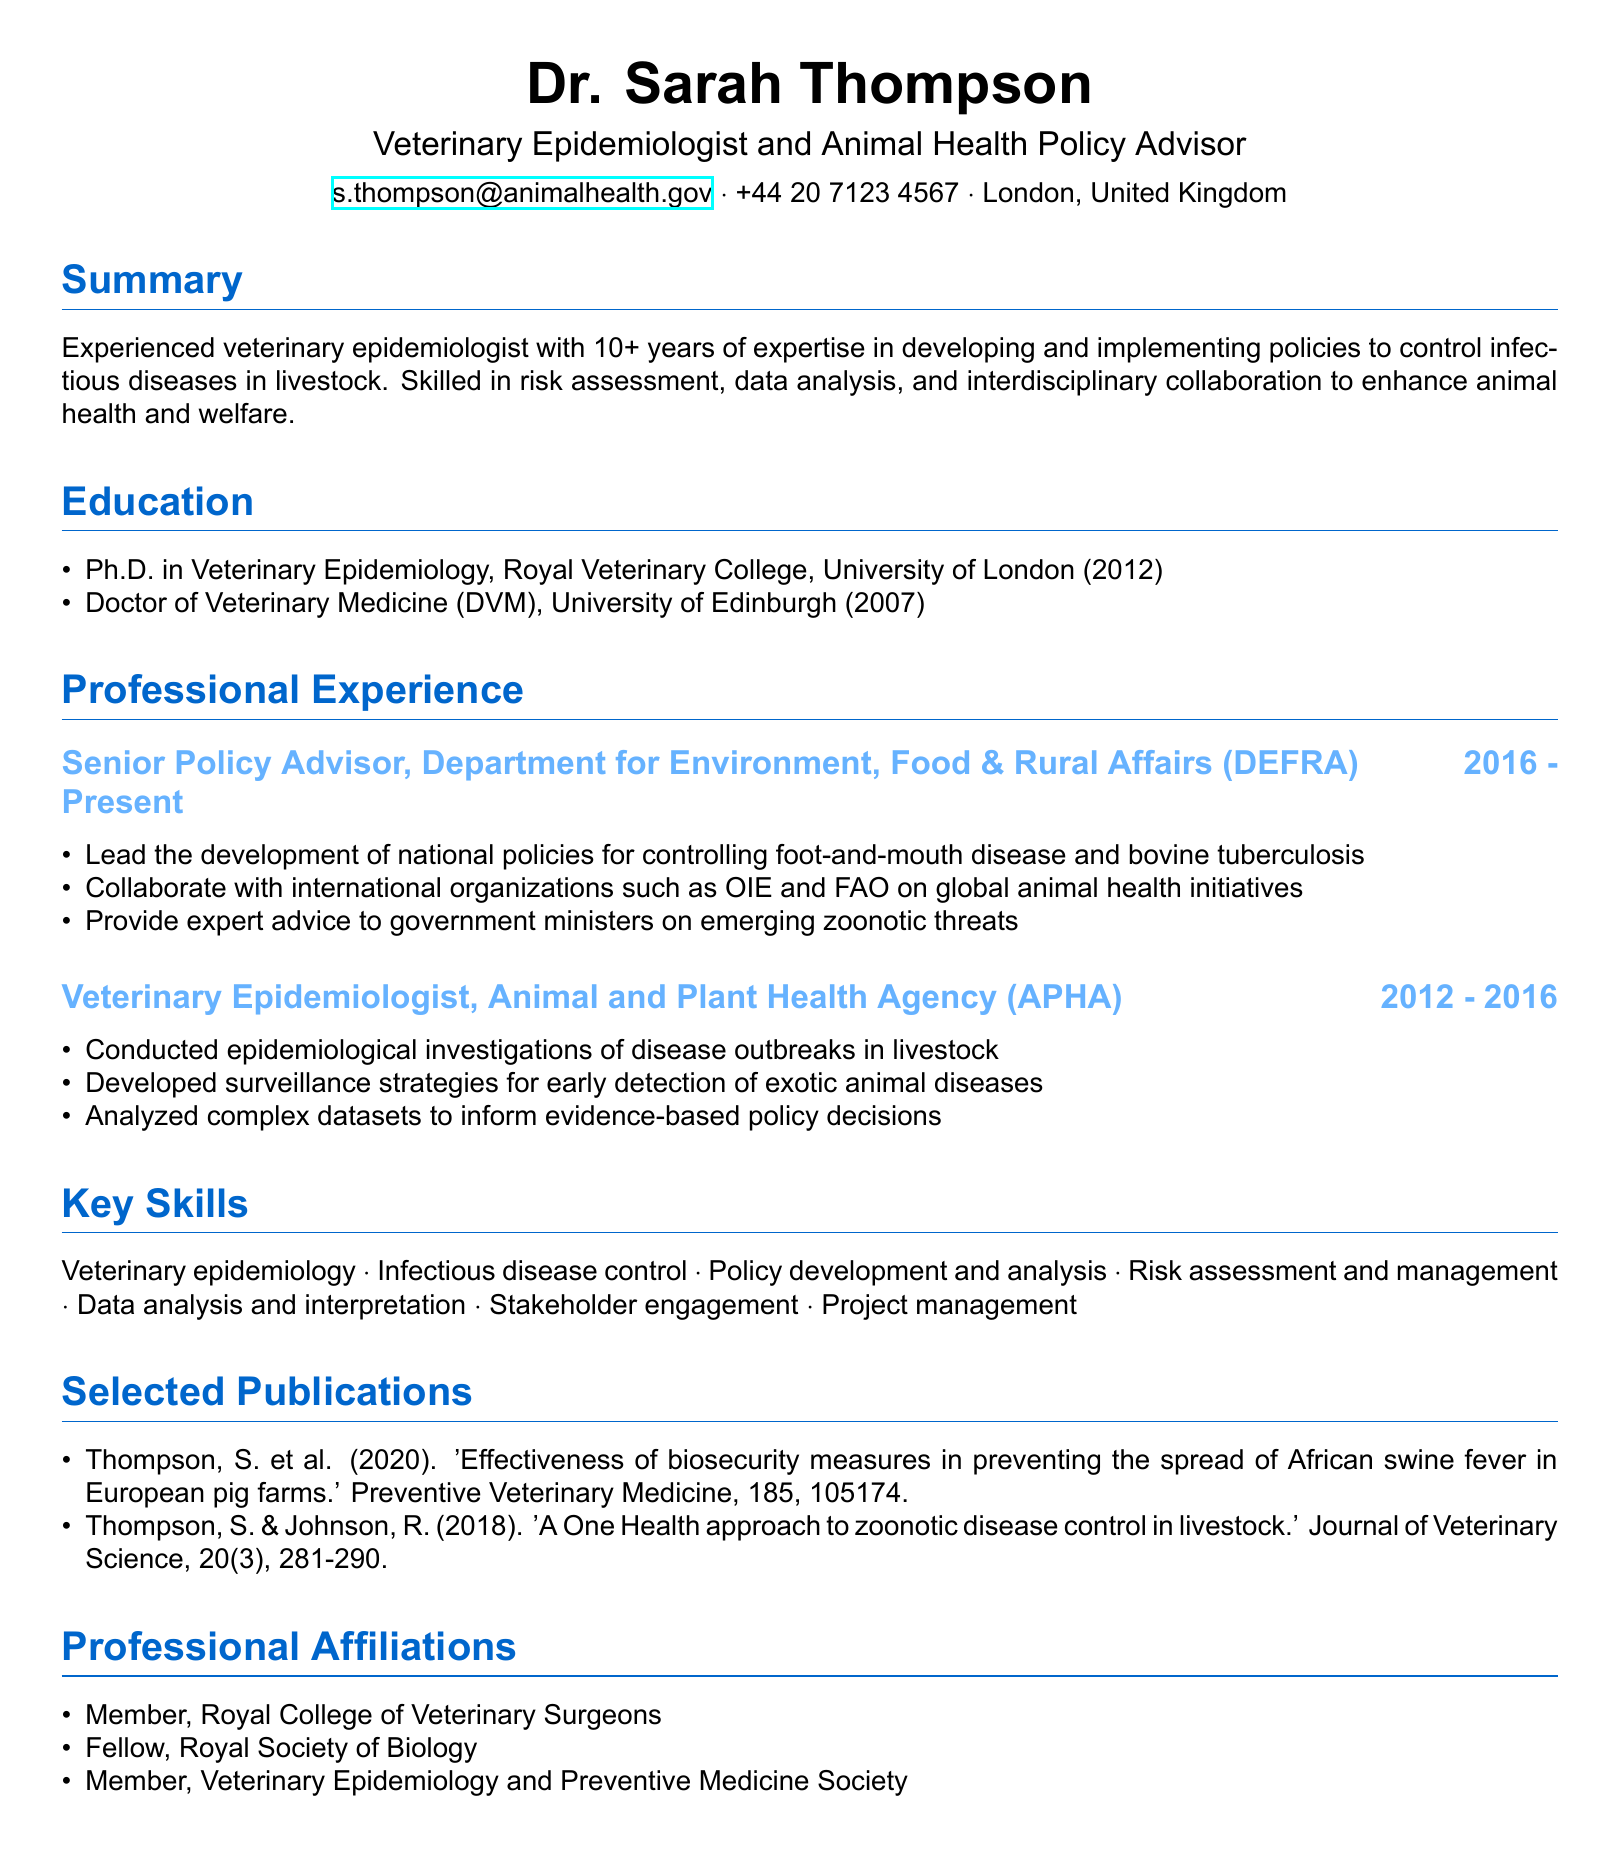What is the name of the CV owner? The name of the CV owner is presented in the personal information section.
Answer: Dr. Sarah Thompson What is Dr. Thompson's current title? The title is listed directly under her name in the personal information section.
Answer: Veterinary Epidemiologist and Animal Health Policy Advisor Which organization does Dr. Thompson work for as a Senior Policy Advisor? The organization is specified in her professional experience section.
Answer: Department for Environment, Food & Rural Affairs (DEFRA) In what year did Dr. Thompson complete her Ph.D.? The year of completion is mentioned in the education section of the CV.
Answer: 2012 How many years of experience does Dr. Thompson have in veterinary epidemiology? The summary provides a specific duration of her experience.
Answer: 10+ years What is one of Dr. Thompson's key skills related to her expertise? Her key skills can be found in a dedicated section of the CV.
Answer: Veterinary epidemiology Which disease does Dr. Thompson help control at DEFRA? This information is mentioned in the responsibilities section of her current role.
Answer: Foot-and-mouth disease Name one of the professional affiliations Dr. Thompson holds. The professional affiliations are listed in a separate section of the CV.
Answer: Member, Royal College of Veterinary Surgeons What type of publications has Dr. Thompson contributed to? The publications section outlines her contributions to specific journals.
Answer: Preventive Veterinary Medicine and Journal of Veterinary Science 